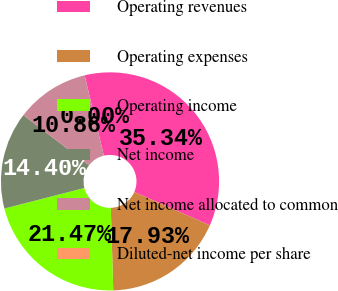Convert chart to OTSL. <chart><loc_0><loc_0><loc_500><loc_500><pie_chart><fcel>Operating revenues<fcel>Operating expenses<fcel>Operating income<fcel>Net income<fcel>Net income allocated to common<fcel>Diluted-net income per share<nl><fcel>35.34%<fcel>17.93%<fcel>21.47%<fcel>14.4%<fcel>10.86%<fcel>0.0%<nl></chart> 